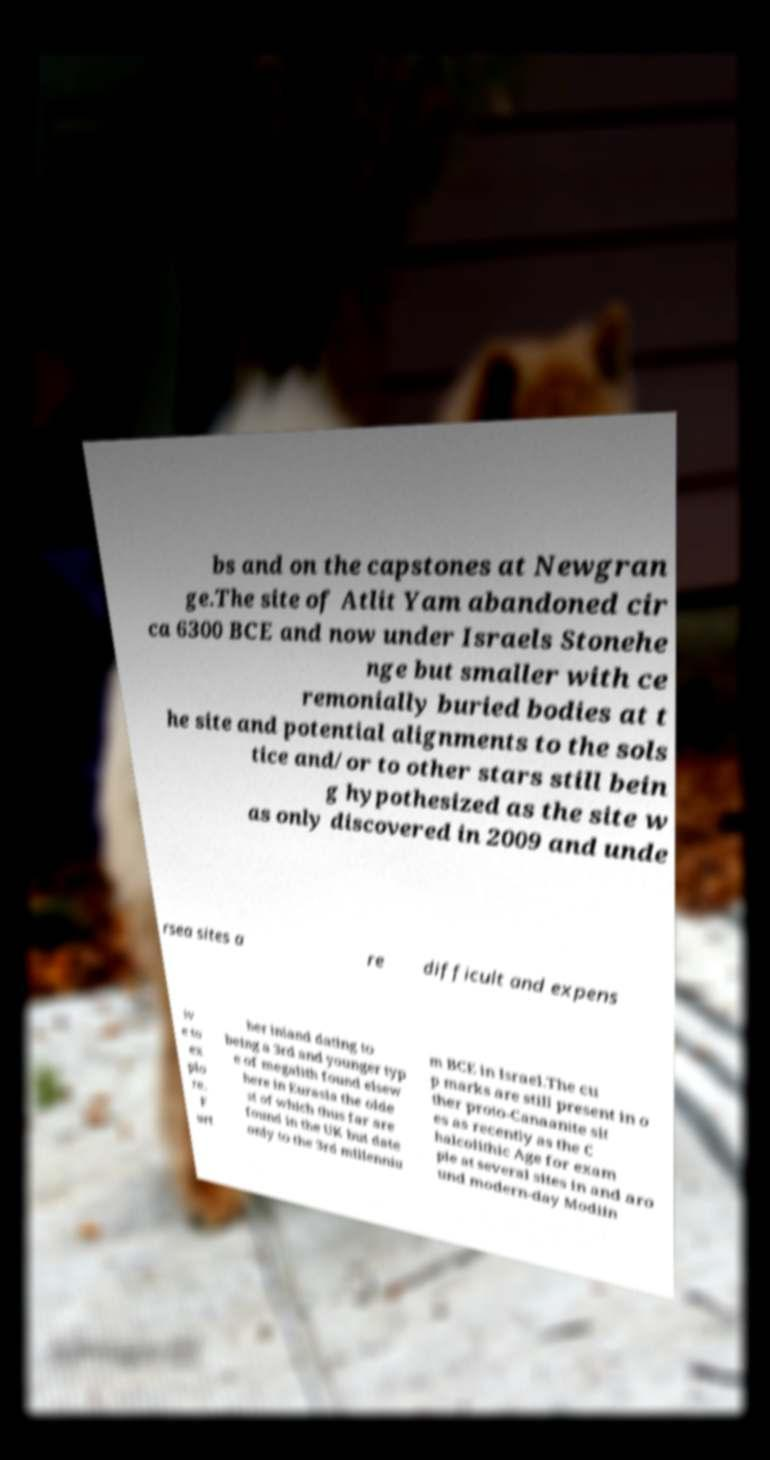There's text embedded in this image that I need extracted. Can you transcribe it verbatim? bs and on the capstones at Newgran ge.The site of Atlit Yam abandoned cir ca 6300 BCE and now under Israels Stonehe nge but smaller with ce remonially buried bodies at t he site and potential alignments to the sols tice and/or to other stars still bein g hypothesized as the site w as only discovered in 2009 and unde rsea sites a re difficult and expens iv e to ex plo re. F urt her inland dating to being a 3rd and younger typ e of megalith found elsew here in Eurasia the olde st of which thus far are found in the UK but date only to the 3rd millenniu m BCE in Israel.The cu p marks are still present in o ther proto-Canaanite sit es as recently as the C halcolithic Age for exam ple at several sites in and aro und modern-day Modiin 